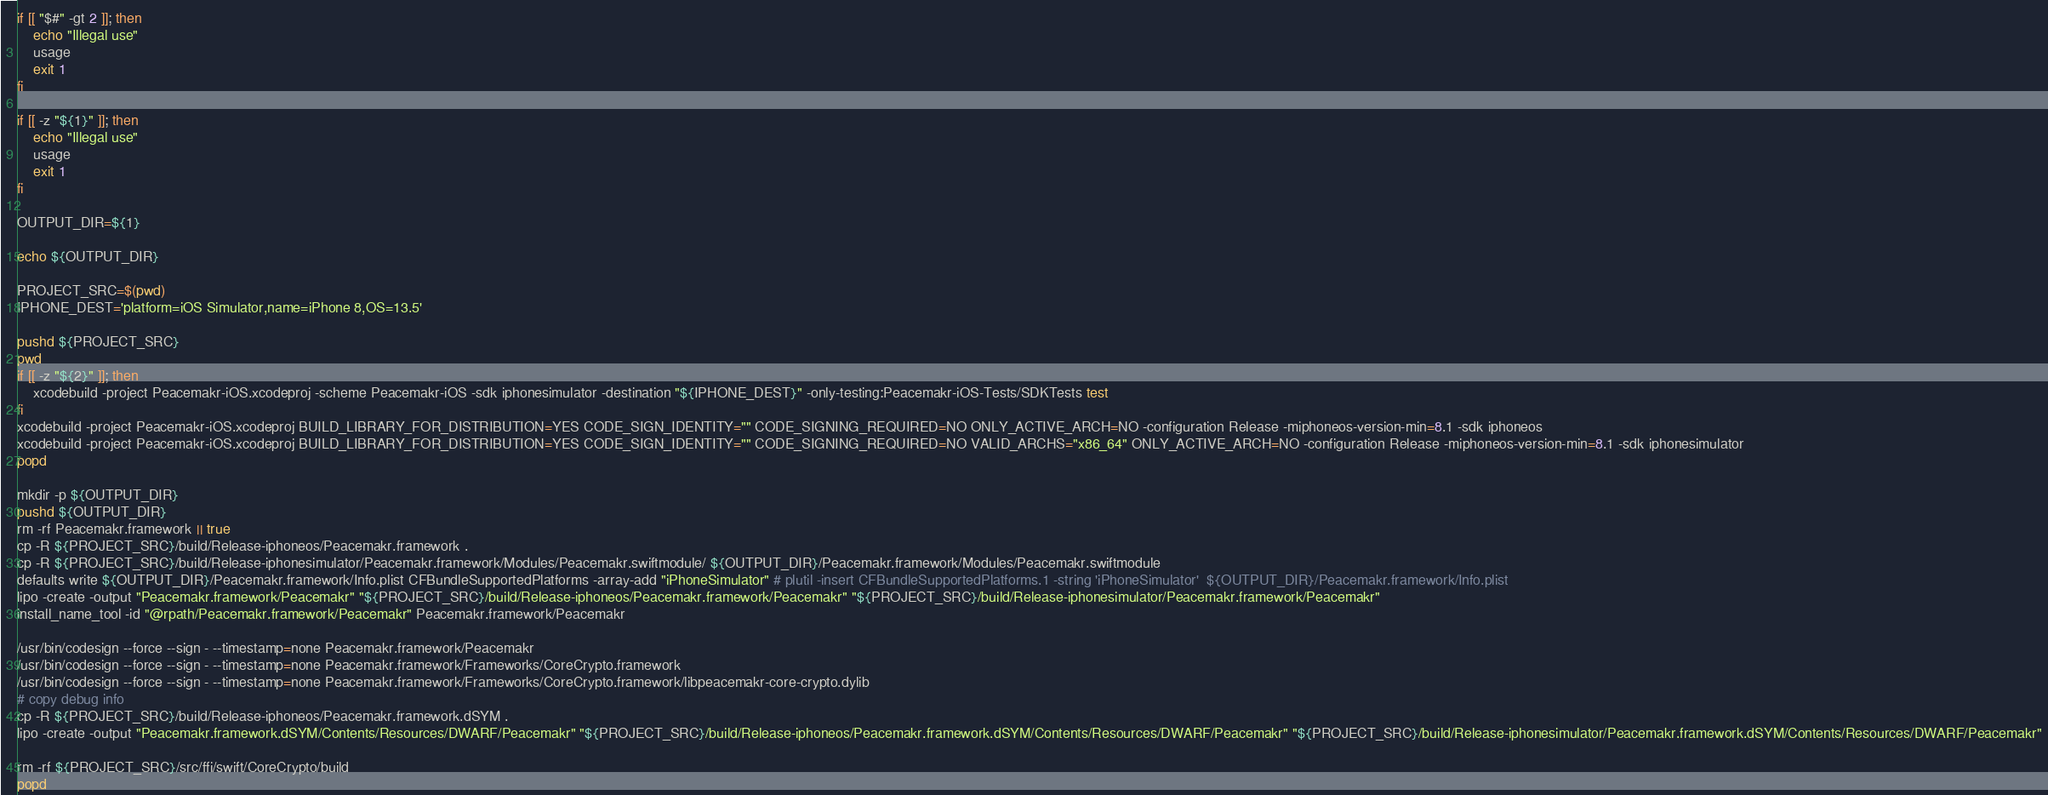Convert code to text. <code><loc_0><loc_0><loc_500><loc_500><_Bash_>
if [[ "$#" -gt 2 ]]; then
    echo "Illegal use"
    usage
    exit 1
fi

if [[ -z "${1}" ]]; then
    echo "Illegal use"
    usage
    exit 1
fi

OUTPUT_DIR=${1}

echo ${OUTPUT_DIR}

PROJECT_SRC=$(pwd)
IPHONE_DEST='platform=iOS Simulator,name=iPhone 8,OS=13.5'

pushd ${PROJECT_SRC}
pwd
if [[ -z "${2}" ]]; then
    xcodebuild -project Peacemakr-iOS.xcodeproj -scheme Peacemakr-iOS -sdk iphonesimulator -destination "${IPHONE_DEST}" -only-testing:Peacemakr-iOS-Tests/SDKTests test
fi
xcodebuild -project Peacemakr-iOS.xcodeproj BUILD_LIBRARY_FOR_DISTRIBUTION=YES CODE_SIGN_IDENTITY="" CODE_SIGNING_REQUIRED=NO ONLY_ACTIVE_ARCH=NO -configuration Release -miphoneos-version-min=8.1 -sdk iphoneos
xcodebuild -project Peacemakr-iOS.xcodeproj BUILD_LIBRARY_FOR_DISTRIBUTION=YES CODE_SIGN_IDENTITY="" CODE_SIGNING_REQUIRED=NO VALID_ARCHS="x86_64" ONLY_ACTIVE_ARCH=NO -configuration Release -miphoneos-version-min=8.1 -sdk iphonesimulator
popd

mkdir -p ${OUTPUT_DIR}
pushd ${OUTPUT_DIR}
rm -rf Peacemakr.framework || true
cp -R ${PROJECT_SRC}/build/Release-iphoneos/Peacemakr.framework .
cp -R ${PROJECT_SRC}/build/Release-iphonesimulator/Peacemakr.framework/Modules/Peacemakr.swiftmodule/ ${OUTPUT_DIR}/Peacemakr.framework/Modules/Peacemakr.swiftmodule
defaults write ${OUTPUT_DIR}/Peacemakr.framework/Info.plist CFBundleSupportedPlatforms -array-add "iPhoneSimulator" # plutil -insert CFBundleSupportedPlatforms.1 -string 'iPhoneSimulator'  ${OUTPUT_DIR}/Peacemakr.framework/Info.plist
lipo -create -output "Peacemakr.framework/Peacemakr" "${PROJECT_SRC}/build/Release-iphoneos/Peacemakr.framework/Peacemakr" "${PROJECT_SRC}/build/Release-iphonesimulator/Peacemakr.framework/Peacemakr"
install_name_tool -id "@rpath/Peacemakr.framework/Peacemakr" Peacemakr.framework/Peacemakr

/usr/bin/codesign --force --sign - --timestamp=none Peacemakr.framework/Peacemakr
/usr/bin/codesign --force --sign - --timestamp=none Peacemakr.framework/Frameworks/CoreCrypto.framework
/usr/bin/codesign --force --sign - --timestamp=none Peacemakr.framework/Frameworks/CoreCrypto.framework/libpeacemakr-core-crypto.dylib
# copy debug info
cp -R ${PROJECT_SRC}/build/Release-iphoneos/Peacemakr.framework.dSYM .
lipo -create -output "Peacemakr.framework.dSYM/Contents/Resources/DWARF/Peacemakr" "${PROJECT_SRC}/build/Release-iphoneos/Peacemakr.framework.dSYM/Contents/Resources/DWARF/Peacemakr" "${PROJECT_SRC}/build/Release-iphonesimulator/Peacemakr.framework.dSYM/Contents/Resources/DWARF/Peacemakr"

rm -rf ${PROJECT_SRC}/src/ffi/swift/CoreCrypto/build
popd


</code> 